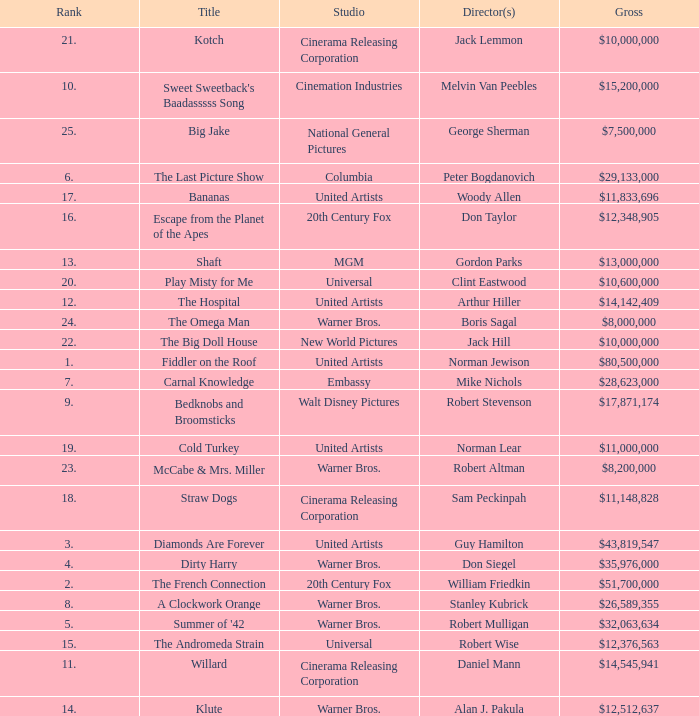What is the rank of The Big Doll House? 22.0. 